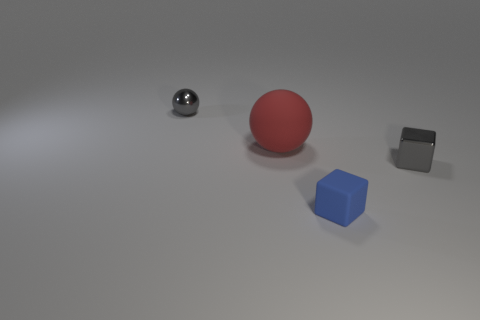Add 4 tiny gray blocks. How many objects exist? 8 Subtract 0 blue cylinders. How many objects are left? 4 Subtract all big purple rubber cylinders. Subtract all big red balls. How many objects are left? 3 Add 2 tiny blue matte objects. How many tiny blue matte objects are left? 3 Add 1 small matte cubes. How many small matte cubes exist? 2 